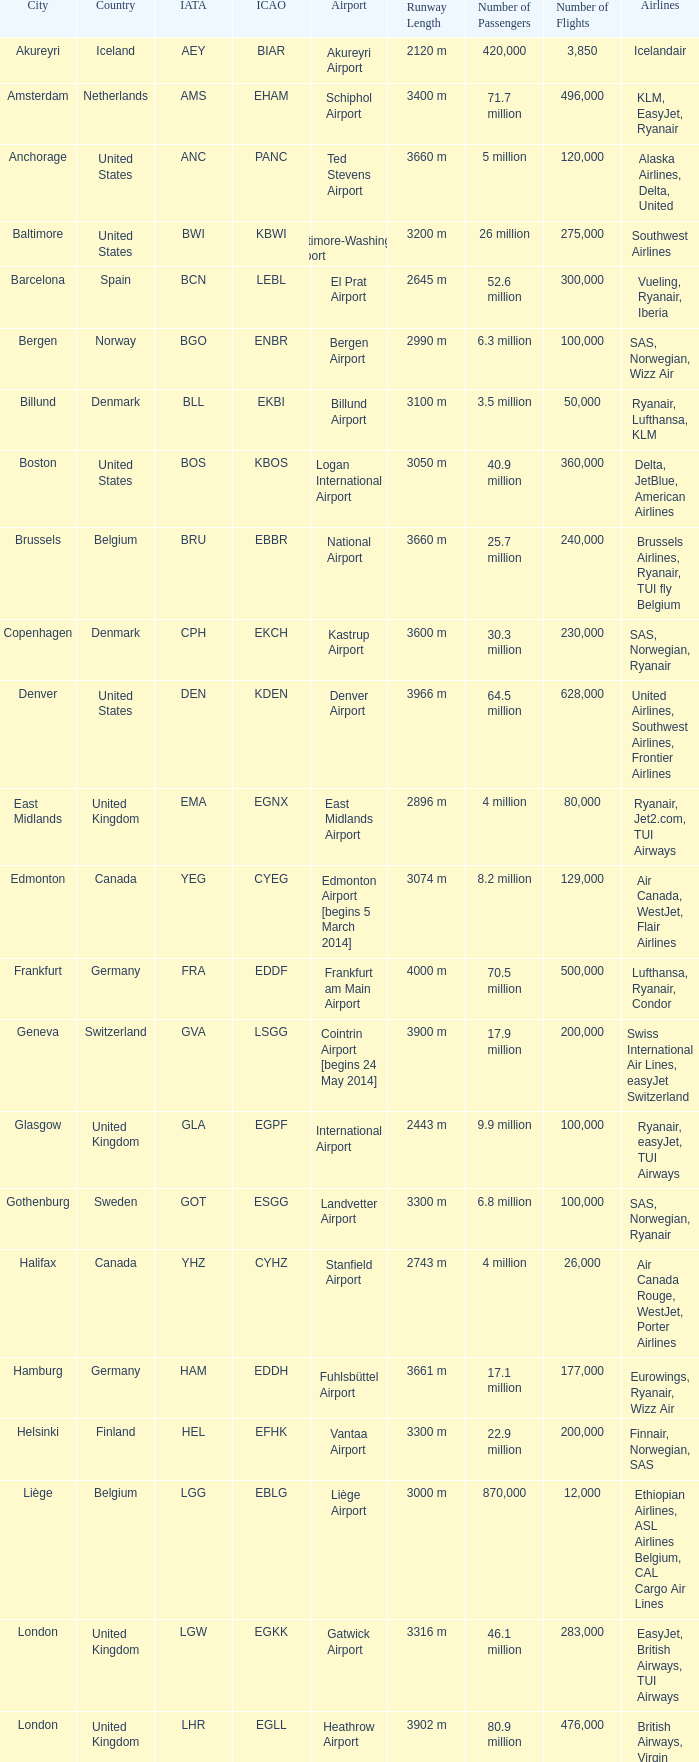What is the Airport with the ICAO fo KSEA? Seattle–Tacoma Airport. 